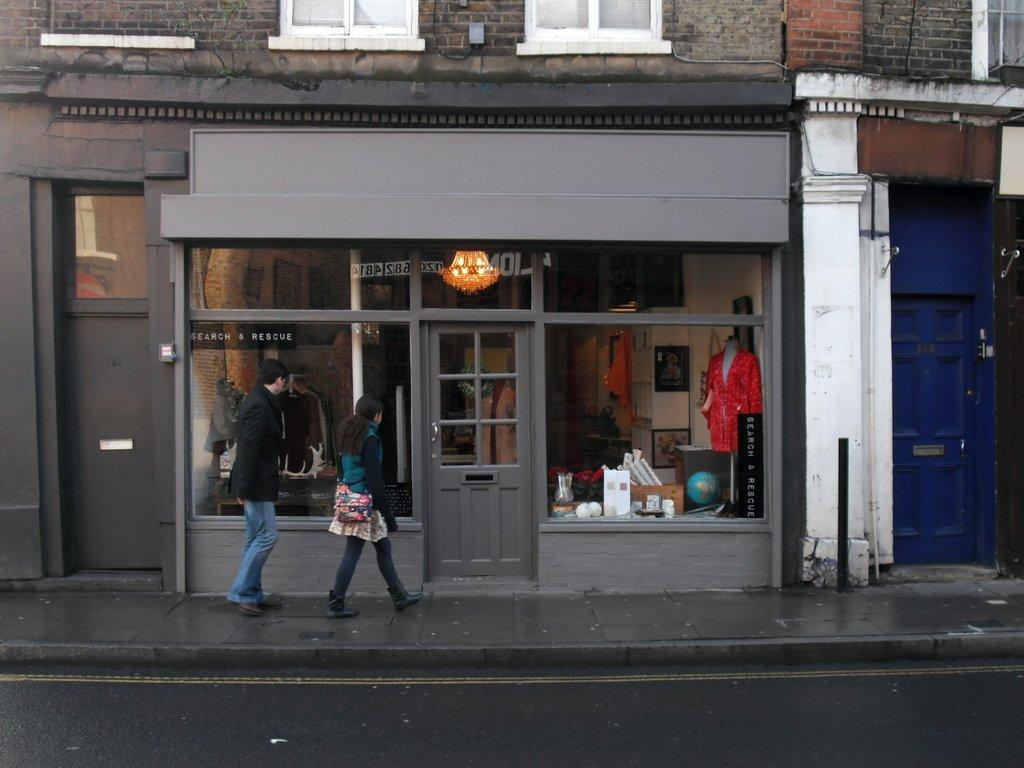What is the main feature of the image? There is a road in the image. What is located beside the road? There is a footpath beside the road. What are the people in the image doing? People (a man and a woman) are walking on the footpath. What can be seen in the background of the image? There is a shop in the background of the image. What is special about the shop's doors? The shop has glass doors. What type of knee injury can be seen in the image? There is no knee injury present in the image; it features a road, a footpath, people walking, and a shop with glass doors. What is the man using to dig in the image? There is no digging tool, such as a rod or rake, present in the image. 